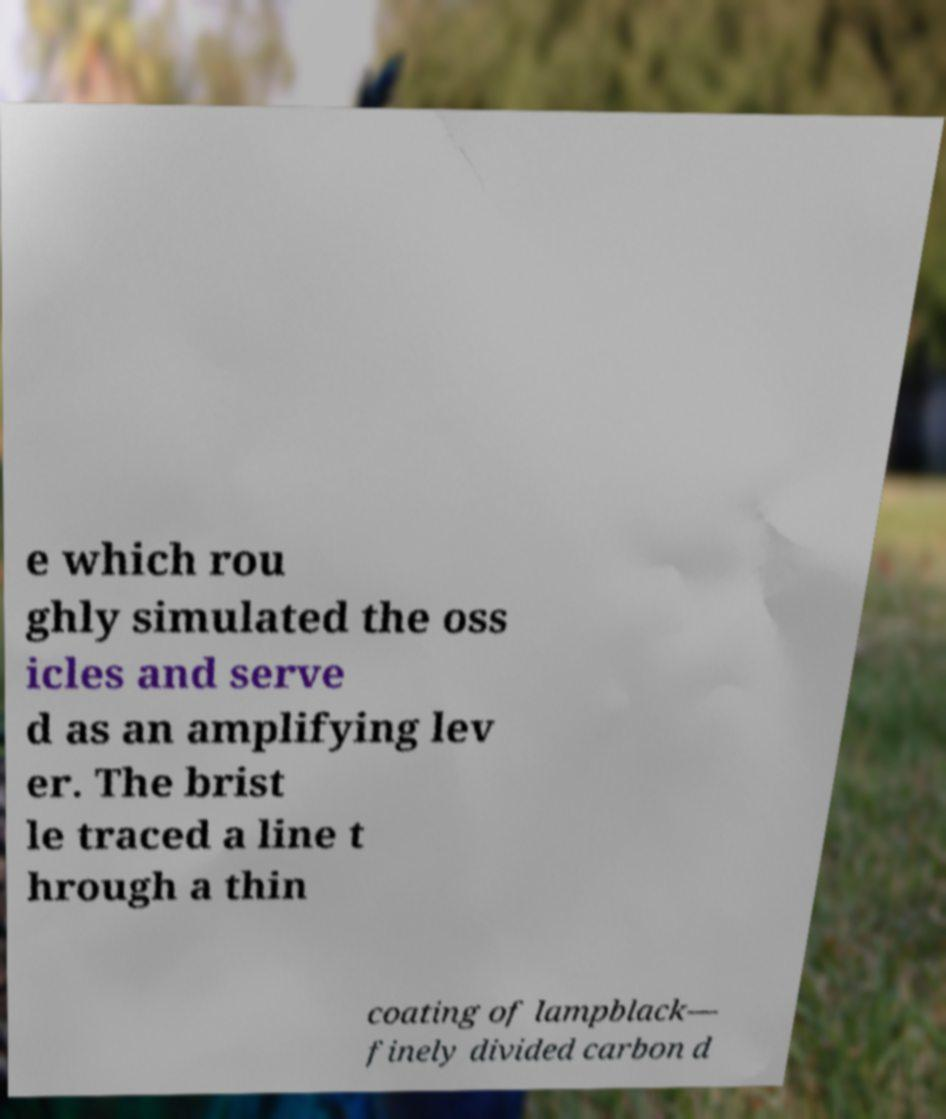Can you accurately transcribe the text from the provided image for me? e which rou ghly simulated the oss icles and serve d as an amplifying lev er. The brist le traced a line t hrough a thin coating of lampblack— finely divided carbon d 